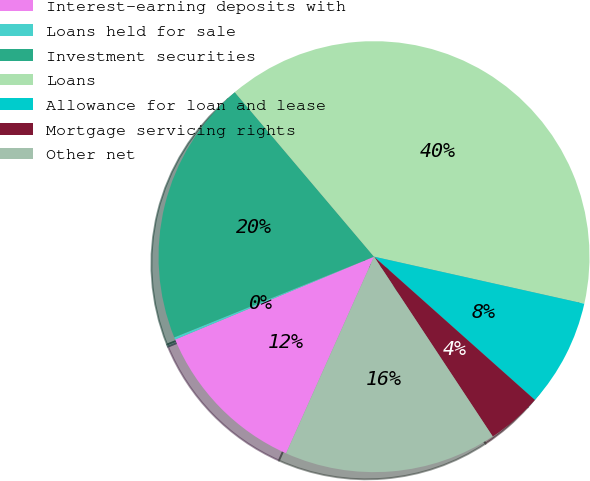<chart> <loc_0><loc_0><loc_500><loc_500><pie_chart><fcel>Interest-earning deposits with<fcel>Loans held for sale<fcel>Investment securities<fcel>Loans<fcel>Allowance for loan and lease<fcel>Mortgage servicing rights<fcel>Other net<nl><fcel>12.03%<fcel>0.17%<fcel>19.93%<fcel>39.69%<fcel>8.08%<fcel>4.13%<fcel>15.98%<nl></chart> 